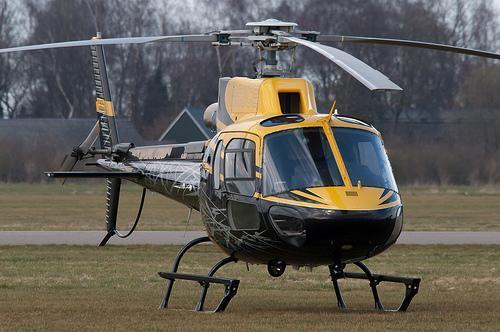How many helicopters in the scene?
Give a very brief answer. 1. 